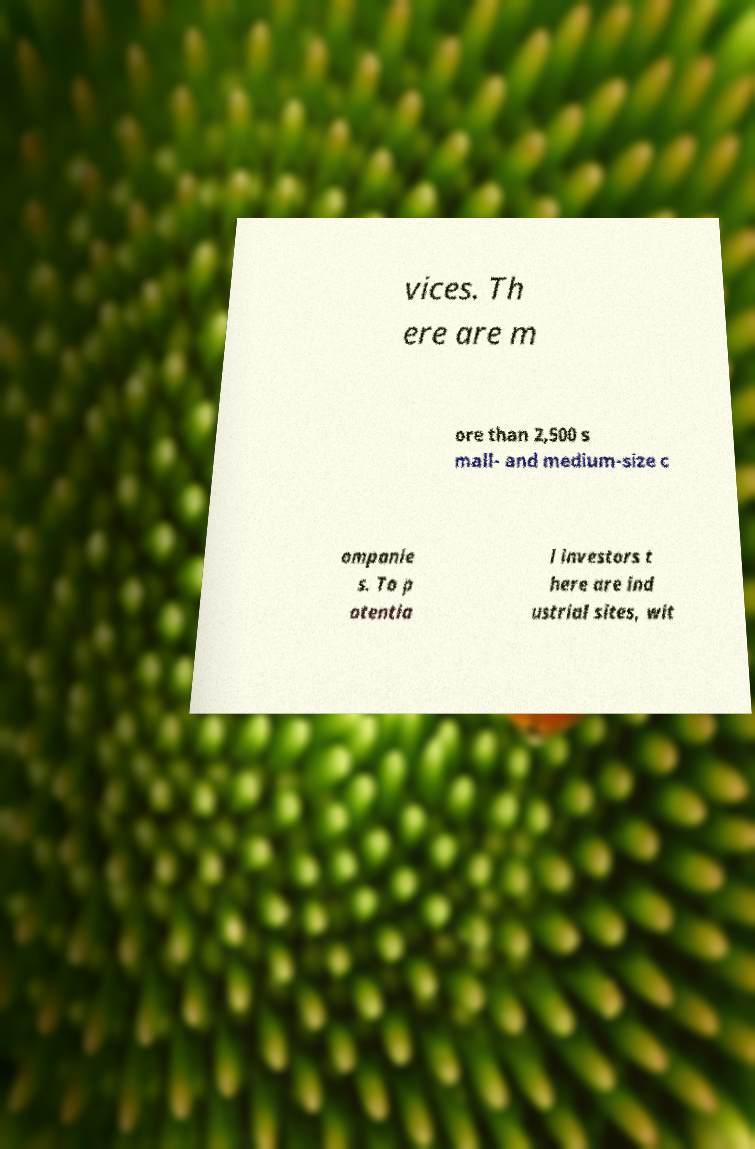Can you read and provide the text displayed in the image?This photo seems to have some interesting text. Can you extract and type it out for me? vices. Th ere are m ore than 2,500 s mall- and medium-size c ompanie s. To p otentia l investors t here are ind ustrial sites, wit 